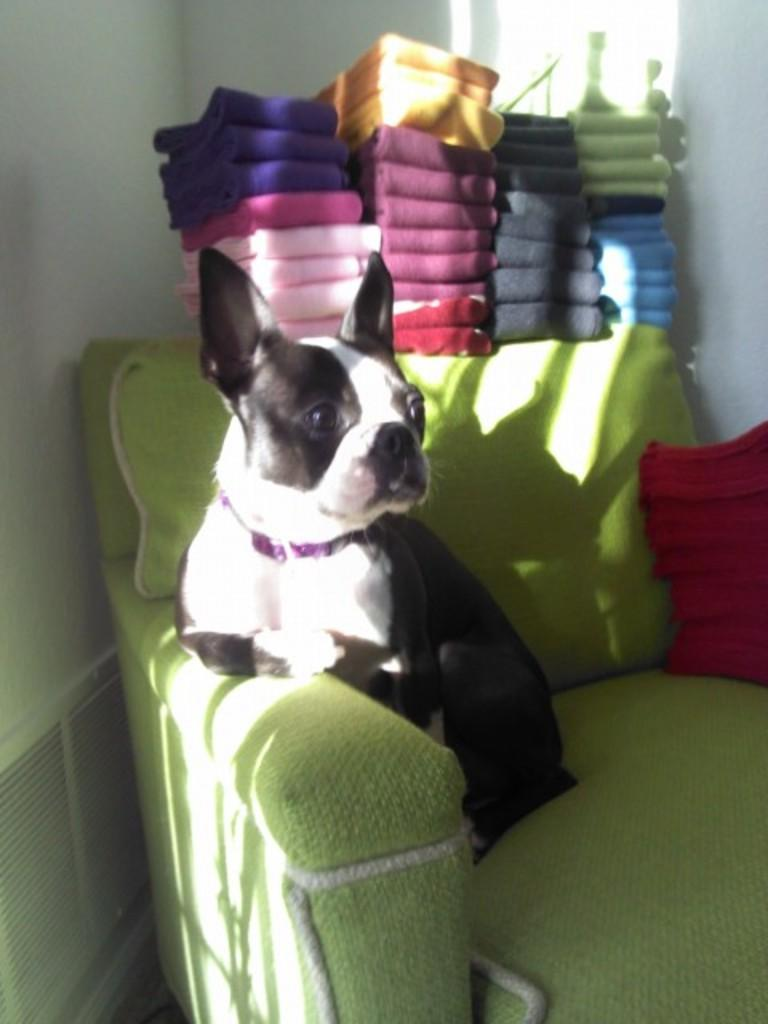What animal can be seen in the image? There is a dog in the image. Where is the dog located? The dog is sitting on a couch. What can be seen in the background of the image? There are towels and a wall visible in the background of the image. What type of zinc detail can be seen on the couch in the image? There is no zinc detail present on the couch in the image. 